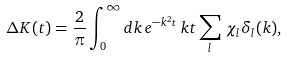<formula> <loc_0><loc_0><loc_500><loc_500>\Delta K ( t ) = \frac { 2 } { \pi } \int _ { 0 } ^ { \infty } d k \, e ^ { - k ^ { 2 } t } \, k t \sum _ { l } \, \chi _ { l } \delta _ { l } ( k ) ,</formula> 